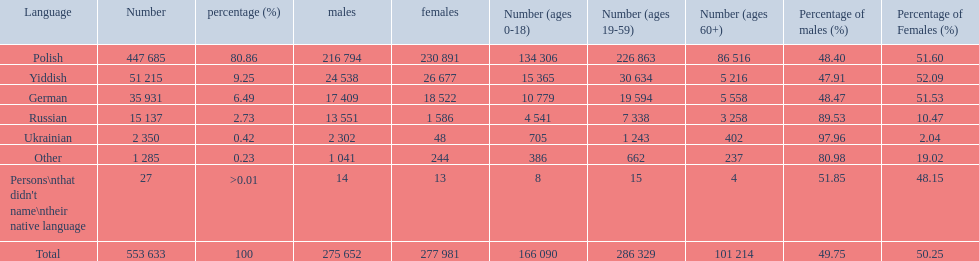How many speakers are represented in polish? 447 685. Parse the full table. {'header': ['Language', 'Number', 'percentage (%)', 'males', 'females', 'Number (ages 0-18)', 'Number (ages 19-59)', 'Number (ages 60+)', 'Percentage of males (%)', 'Percentage of Females (%)'], 'rows': [['Polish', '447 685', '80.86', '216 794', '230 891', '134 306', '226 863', '86 516', '48.40', '51.60'], ['Yiddish', '51 215', '9.25', '24 538', '26 677', '15 365', '30 634', '5 216', '47.91', '52.09'], ['German', '35 931', '6.49', '17 409', '18 522', '10 779', '19 594', '5 558', '48.47', '51.53'], ['Russian', '15 137', '2.73', '13 551', '1 586', '4 541', '7 338', '3 258', '89.53', '10.47'], ['Ukrainian', '2 350', '0.42', '2 302', '48', '705', '1 243', '402', '97.96', '2.04'], ['Other', '1 285', '0.23', '1 041', '244', '386', '662', '237', '80.98', '19.02'], ["Persons\\nthat didn't name\\ntheir native language", '27', '>0.01', '14', '13', '8', '15', '4', '51.85', '48.15'], ['Total', '553 633', '100', '275 652', '277 981', '166 090', '286 329', '101 214', '49.75', '50.25']]} How many represented speakers are yiddish? 51 215. What is the total number of speakers? 553 633. 